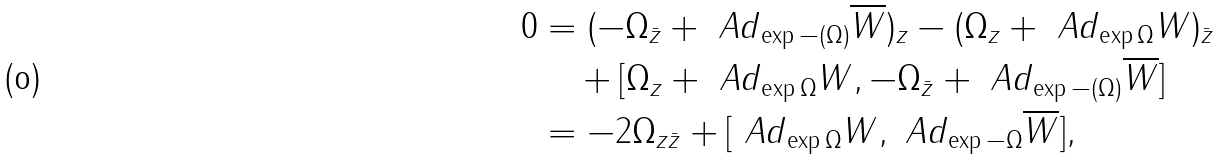Convert formula to latex. <formula><loc_0><loc_0><loc_500><loc_500>0 & = ( - { \Omega } _ { \bar { z } } + { \ A d } _ { \exp - ( \Omega ) } { \overline { W } } ) _ { z } - ( { \Omega } _ { z } + { \ A d } _ { \exp { \Omega } } W ) _ { \bar { z } } \\ & \quad + [ { \Omega } _ { z } + { \ A d } _ { \exp { \Omega } } W , - { \Omega } _ { \bar { z } } + { \ A d } _ { \exp - ( \Omega ) } { \overline { W } } ] \\ & = - 2 { \Omega } _ { z \bar { z } } + [ { \ A d } _ { \exp { \Omega } } W , { \ A d } _ { \exp - { \Omega } } { \overline { W } } ] ,</formula> 